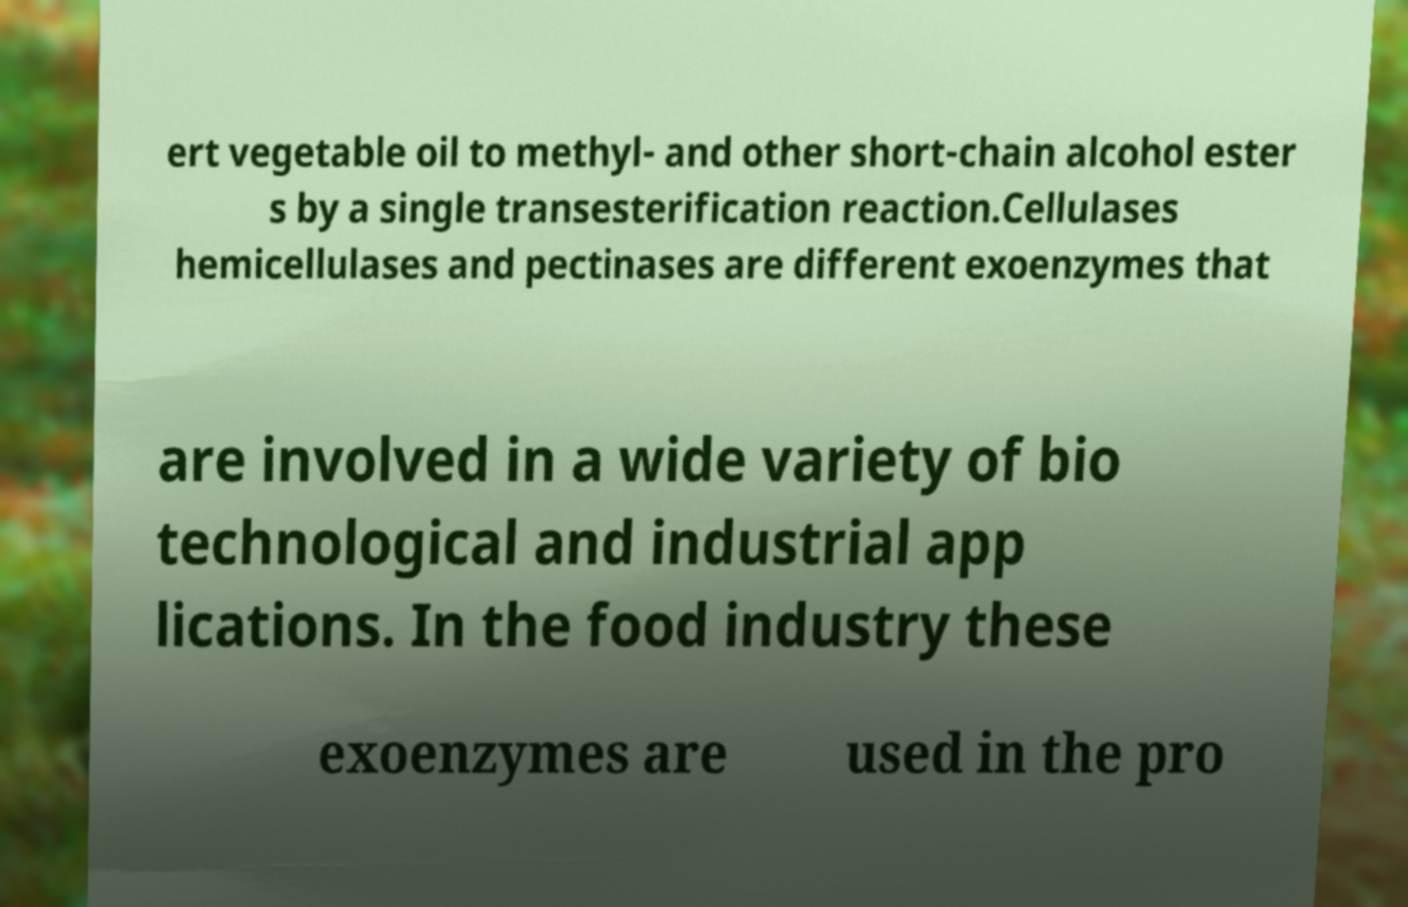Please identify and transcribe the text found in this image. ert vegetable oil to methyl- and other short-chain alcohol ester s by a single transesterification reaction.Cellulases hemicellulases and pectinases are different exoenzymes that are involved in a wide variety of bio technological and industrial app lications. In the food industry these exoenzymes are used in the pro 